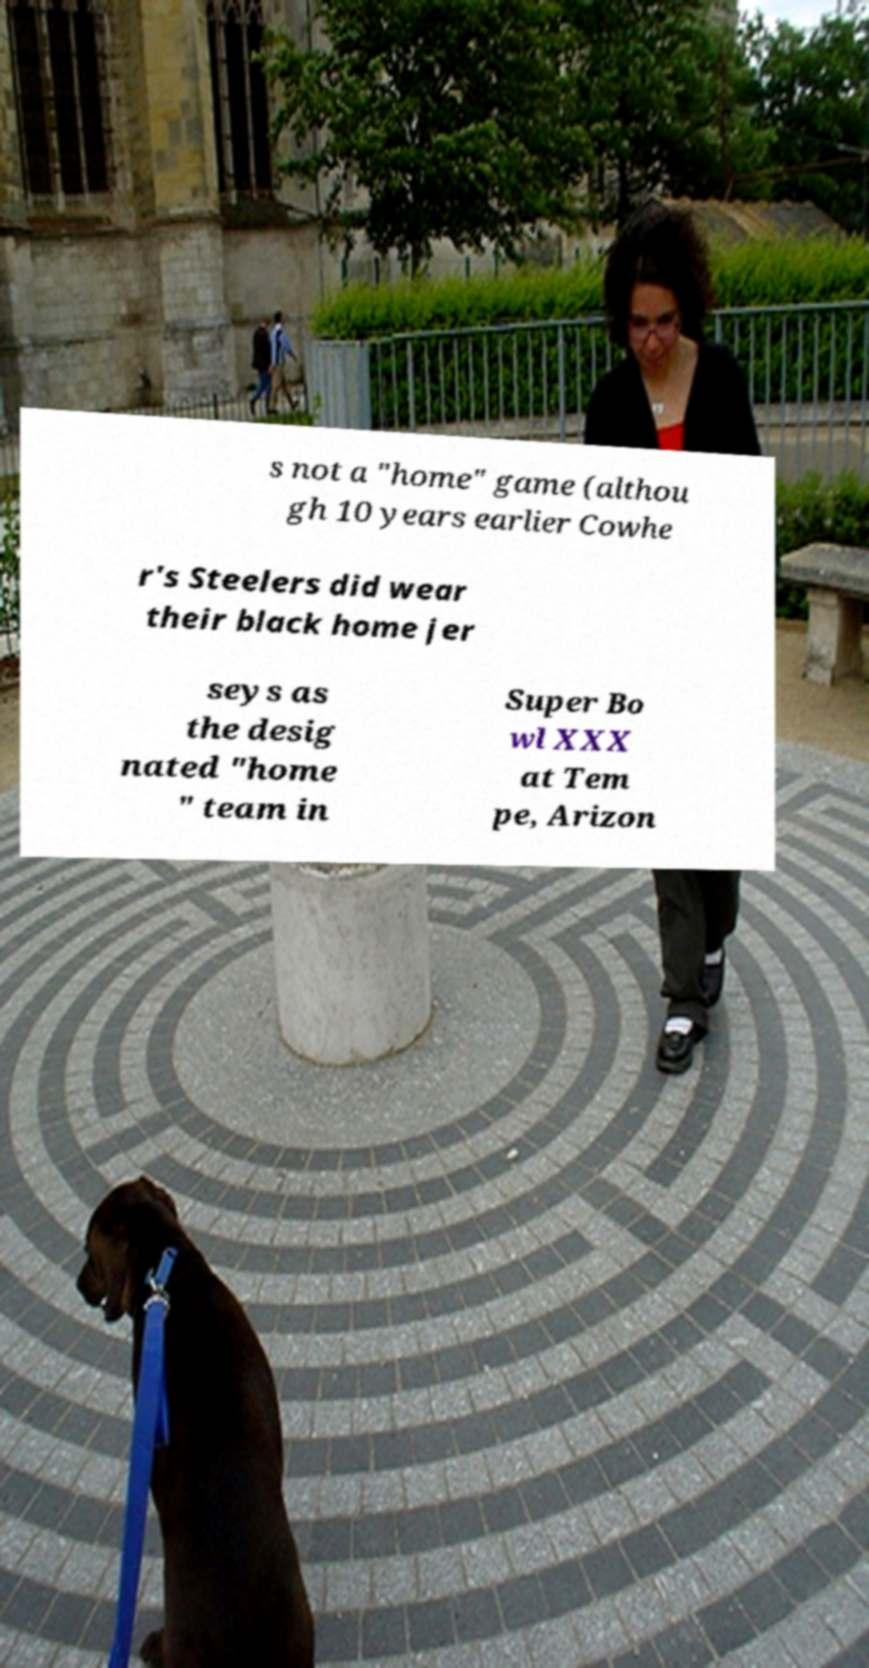Please identify and transcribe the text found in this image. s not a "home" game (althou gh 10 years earlier Cowhe r's Steelers did wear their black home jer seys as the desig nated "home " team in Super Bo wl XXX at Tem pe, Arizon 